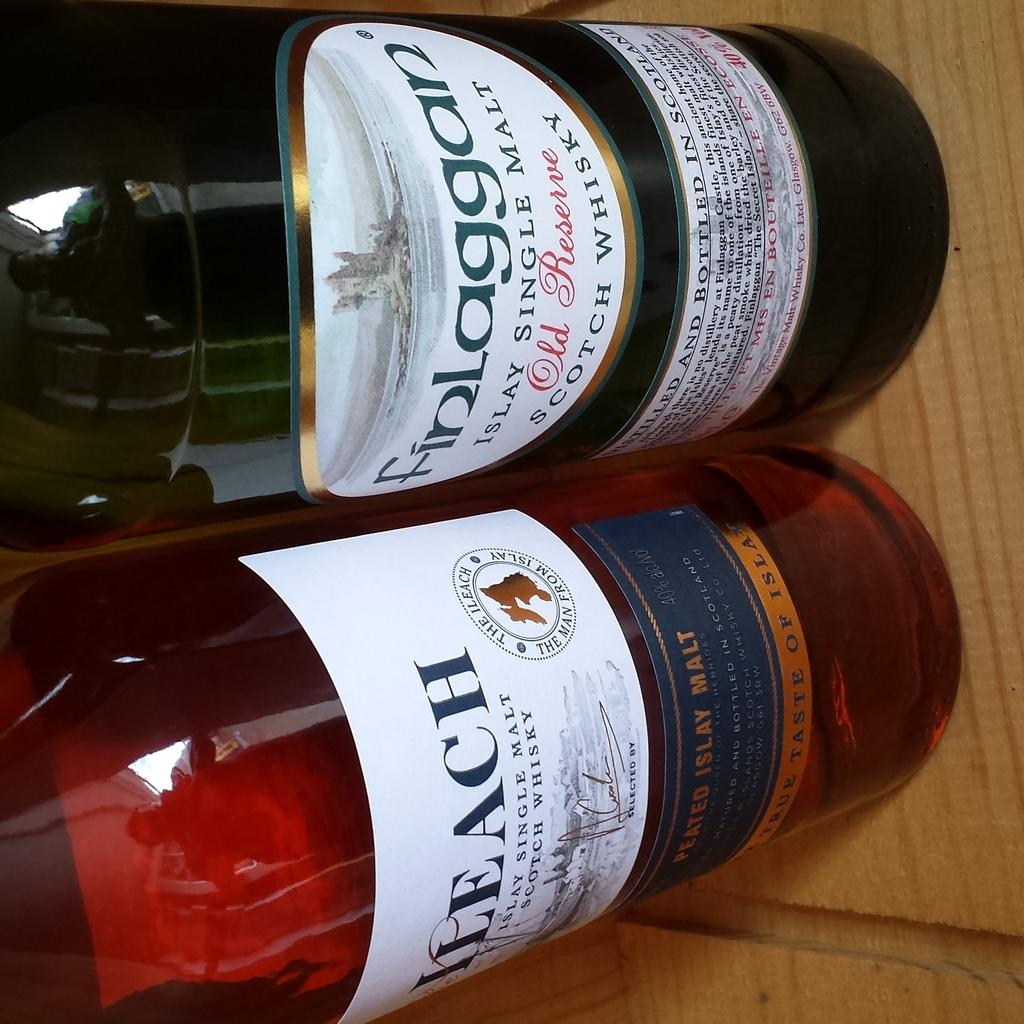Provide a one-sentence caption for the provided image. A couple of bottles sit next to each other on the table and one says Finlaggan. 